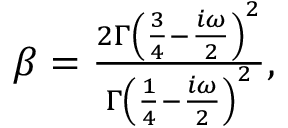Convert formula to latex. <formula><loc_0><loc_0><loc_500><loc_500>\begin{array} { r } { \beta = \frac { 2 \Gamma \left ( \frac { 3 } { 4 } - \frac { i \omega } { 2 } \right ) ^ { 2 } } { \Gamma \left ( \frac { 1 } { 4 } - \frac { i \omega } { 2 } \right ) ^ { 2 } } , } \end{array}</formula> 